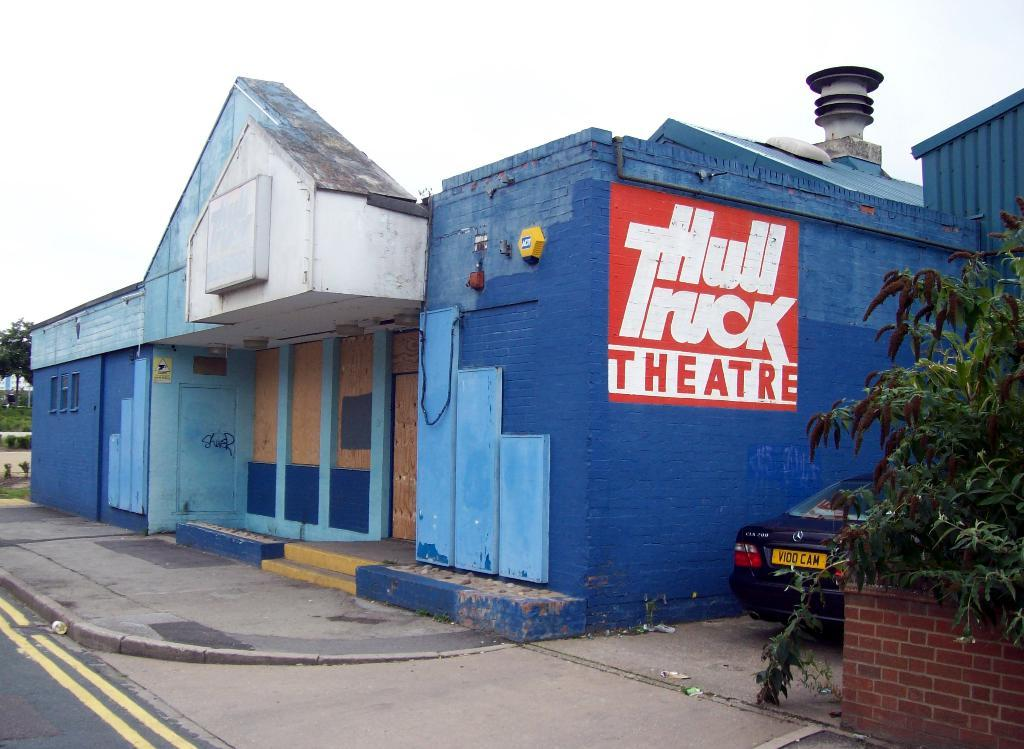What type of structure is visible in the image? There is a building in the image. What is located to the right of the building? There is a plant and a brick wall to the right of the building. What else can be seen to the right of the building? There is also a vehicle to the right of the building. What can be seen in the background of the image? There are trees and the sky visible in the background of the image. How far away is the copy of the building in the image? There is no copy of the building present in the image. What tool is being used to hammer the trees in the background of the image? There is no hammer or tree-hammering activity depicted in the image. 